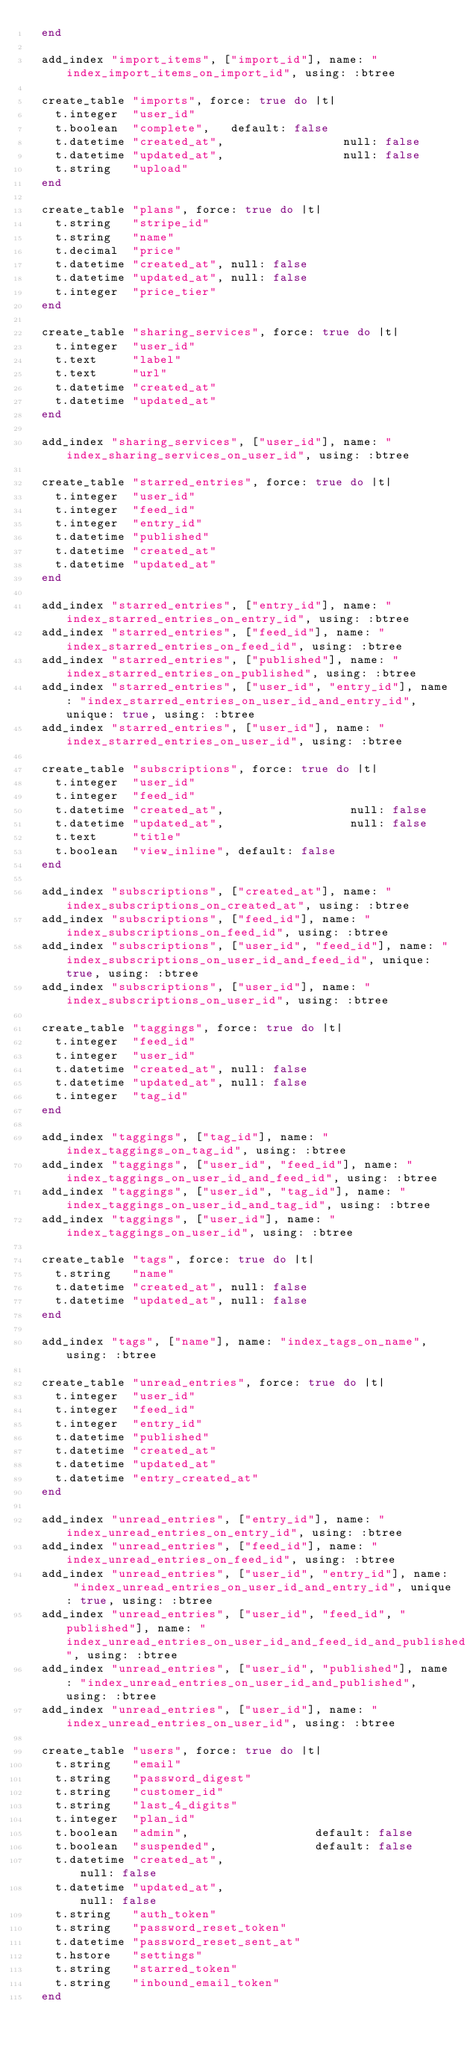Convert code to text. <code><loc_0><loc_0><loc_500><loc_500><_Ruby_>  end

  add_index "import_items", ["import_id"], name: "index_import_items_on_import_id", using: :btree

  create_table "imports", force: true do |t|
    t.integer  "user_id"
    t.boolean  "complete",   default: false
    t.datetime "created_at",                 null: false
    t.datetime "updated_at",                 null: false
    t.string   "upload"
  end

  create_table "plans", force: true do |t|
    t.string   "stripe_id"
    t.string   "name"
    t.decimal  "price"
    t.datetime "created_at", null: false
    t.datetime "updated_at", null: false
    t.integer  "price_tier"
  end

  create_table "sharing_services", force: true do |t|
    t.integer  "user_id"
    t.text     "label"
    t.text     "url"
    t.datetime "created_at"
    t.datetime "updated_at"
  end

  add_index "sharing_services", ["user_id"], name: "index_sharing_services_on_user_id", using: :btree

  create_table "starred_entries", force: true do |t|
    t.integer  "user_id"
    t.integer  "feed_id"
    t.integer  "entry_id"
    t.datetime "published"
    t.datetime "created_at"
    t.datetime "updated_at"
  end

  add_index "starred_entries", ["entry_id"], name: "index_starred_entries_on_entry_id", using: :btree
  add_index "starred_entries", ["feed_id"], name: "index_starred_entries_on_feed_id", using: :btree
  add_index "starred_entries", ["published"], name: "index_starred_entries_on_published", using: :btree
  add_index "starred_entries", ["user_id", "entry_id"], name: "index_starred_entries_on_user_id_and_entry_id", unique: true, using: :btree
  add_index "starred_entries", ["user_id"], name: "index_starred_entries_on_user_id", using: :btree

  create_table "subscriptions", force: true do |t|
    t.integer  "user_id"
    t.integer  "feed_id"
    t.datetime "created_at",                  null: false
    t.datetime "updated_at",                  null: false
    t.text     "title"
    t.boolean  "view_inline", default: false
  end

  add_index "subscriptions", ["created_at"], name: "index_subscriptions_on_created_at", using: :btree
  add_index "subscriptions", ["feed_id"], name: "index_subscriptions_on_feed_id", using: :btree
  add_index "subscriptions", ["user_id", "feed_id"], name: "index_subscriptions_on_user_id_and_feed_id", unique: true, using: :btree
  add_index "subscriptions", ["user_id"], name: "index_subscriptions_on_user_id", using: :btree

  create_table "taggings", force: true do |t|
    t.integer  "feed_id"
    t.integer  "user_id"
    t.datetime "created_at", null: false
    t.datetime "updated_at", null: false
    t.integer  "tag_id"
  end

  add_index "taggings", ["tag_id"], name: "index_taggings_on_tag_id", using: :btree
  add_index "taggings", ["user_id", "feed_id"], name: "index_taggings_on_user_id_and_feed_id", using: :btree
  add_index "taggings", ["user_id", "tag_id"], name: "index_taggings_on_user_id_and_tag_id", using: :btree
  add_index "taggings", ["user_id"], name: "index_taggings_on_user_id", using: :btree

  create_table "tags", force: true do |t|
    t.string   "name"
    t.datetime "created_at", null: false
    t.datetime "updated_at", null: false
  end

  add_index "tags", ["name"], name: "index_tags_on_name", using: :btree

  create_table "unread_entries", force: true do |t|
    t.integer  "user_id"
    t.integer  "feed_id"
    t.integer  "entry_id"
    t.datetime "published"
    t.datetime "created_at"
    t.datetime "updated_at"
    t.datetime "entry_created_at"
  end

  add_index "unread_entries", ["entry_id"], name: "index_unread_entries_on_entry_id", using: :btree
  add_index "unread_entries", ["feed_id"], name: "index_unread_entries_on_feed_id", using: :btree
  add_index "unread_entries", ["user_id", "entry_id"], name: "index_unread_entries_on_user_id_and_entry_id", unique: true, using: :btree
  add_index "unread_entries", ["user_id", "feed_id", "published"], name: "index_unread_entries_on_user_id_and_feed_id_and_published", using: :btree
  add_index "unread_entries", ["user_id", "published"], name: "index_unread_entries_on_user_id_and_published", using: :btree
  add_index "unread_entries", ["user_id"], name: "index_unread_entries_on_user_id", using: :btree

  create_table "users", force: true do |t|
    t.string   "email"
    t.string   "password_digest"
    t.string   "customer_id"
    t.string   "last_4_digits"
    t.integer  "plan_id"
    t.boolean  "admin",                  default: false
    t.boolean  "suspended",              default: false
    t.datetime "created_at",                             null: false
    t.datetime "updated_at",                             null: false
    t.string   "auth_token"
    t.string   "password_reset_token"
    t.datetime "password_reset_sent_at"
    t.hstore   "settings"
    t.string   "starred_token"
    t.string   "inbound_email_token"
  end
</code> 